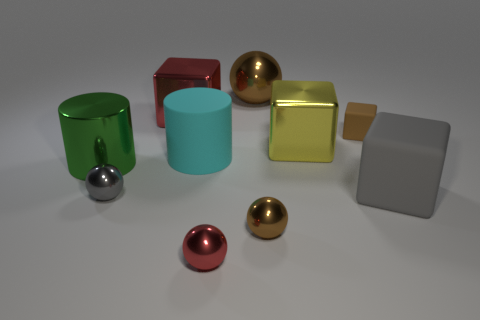Is there another metallic thing of the same shape as the gray metal object?
Offer a very short reply. Yes. How many objects are either tiny metal things that are to the left of the small brown metallic thing or large red objects?
Your response must be concise. 3. Are there more small brown metallic cubes than red balls?
Offer a terse response. No. Is there a brown ball of the same size as the red metallic sphere?
Provide a succinct answer. Yes. How many things are either matte things to the left of the large shiny ball or brown shiny spheres in front of the large yellow block?
Offer a terse response. 2. There is a tiny metallic object that is in front of the brown thing that is in front of the yellow metal cube; what color is it?
Your answer should be compact. Red. What color is the cylinder that is the same material as the large brown object?
Your response must be concise. Green. How many large blocks have the same color as the small matte cube?
Make the answer very short. 0. How many objects are red spheres or cyan balls?
Give a very brief answer. 1. What is the shape of the green metallic thing that is the same size as the gray rubber thing?
Give a very brief answer. Cylinder. 